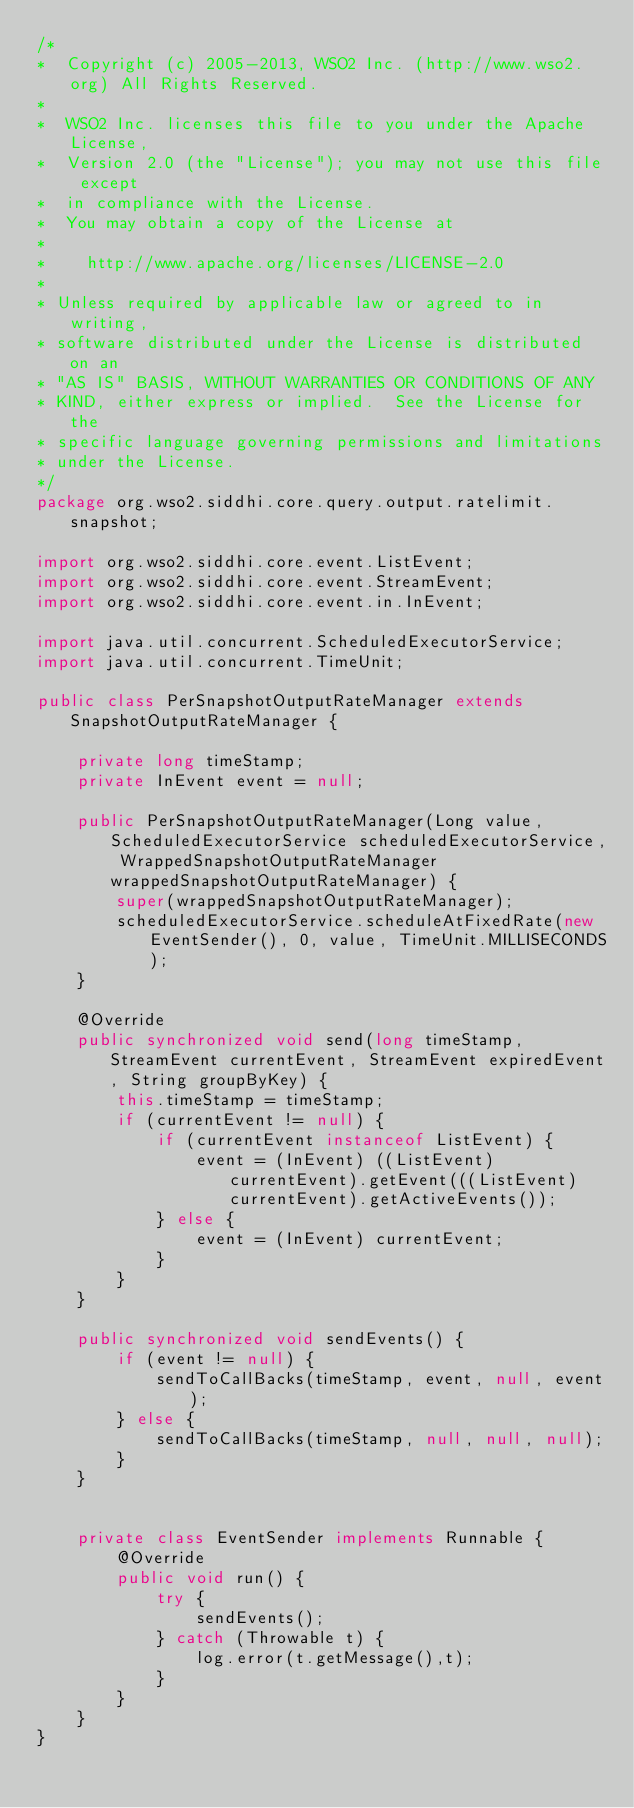<code> <loc_0><loc_0><loc_500><loc_500><_Java_>/*
*  Copyright (c) 2005-2013, WSO2 Inc. (http://www.wso2.org) All Rights Reserved.
*
*  WSO2 Inc. licenses this file to you under the Apache License,
*  Version 2.0 (the "License"); you may not use this file except
*  in compliance with the License.
*  You may obtain a copy of the License at
*
*    http://www.apache.org/licenses/LICENSE-2.0
*
* Unless required by applicable law or agreed to in writing,
* software distributed under the License is distributed on an
* "AS IS" BASIS, WITHOUT WARRANTIES OR CONDITIONS OF ANY
* KIND, either express or implied.  See the License for the
* specific language governing permissions and limitations
* under the License.
*/
package org.wso2.siddhi.core.query.output.ratelimit.snapshot;

import org.wso2.siddhi.core.event.ListEvent;
import org.wso2.siddhi.core.event.StreamEvent;
import org.wso2.siddhi.core.event.in.InEvent;

import java.util.concurrent.ScheduledExecutorService;
import java.util.concurrent.TimeUnit;

public class PerSnapshotOutputRateManager extends SnapshotOutputRateManager {

    private long timeStamp;
    private InEvent event = null;

    public PerSnapshotOutputRateManager(Long value, ScheduledExecutorService scheduledExecutorService, WrappedSnapshotOutputRateManager wrappedSnapshotOutputRateManager) {
        super(wrappedSnapshotOutputRateManager);
        scheduledExecutorService.scheduleAtFixedRate(new EventSender(), 0, value, TimeUnit.MILLISECONDS);
    }

    @Override
    public synchronized void send(long timeStamp, StreamEvent currentEvent, StreamEvent expiredEvent, String groupByKey) {
        this.timeStamp = timeStamp;
        if (currentEvent != null) {
            if (currentEvent instanceof ListEvent) {
                event = (InEvent) ((ListEvent) currentEvent).getEvent(((ListEvent) currentEvent).getActiveEvents());
            } else {
                event = (InEvent) currentEvent;
            }
        }
    }

    public synchronized void sendEvents() {
        if (event != null) {
            sendToCallBacks(timeStamp, event, null, event);
        } else {
            sendToCallBacks(timeStamp, null, null, null);
        }
    }


    private class EventSender implements Runnable {
        @Override
        public void run() {
            try {
                sendEvents();
            } catch (Throwable t) {
                log.error(t.getMessage(),t);
            }
        }
    }
}
</code> 